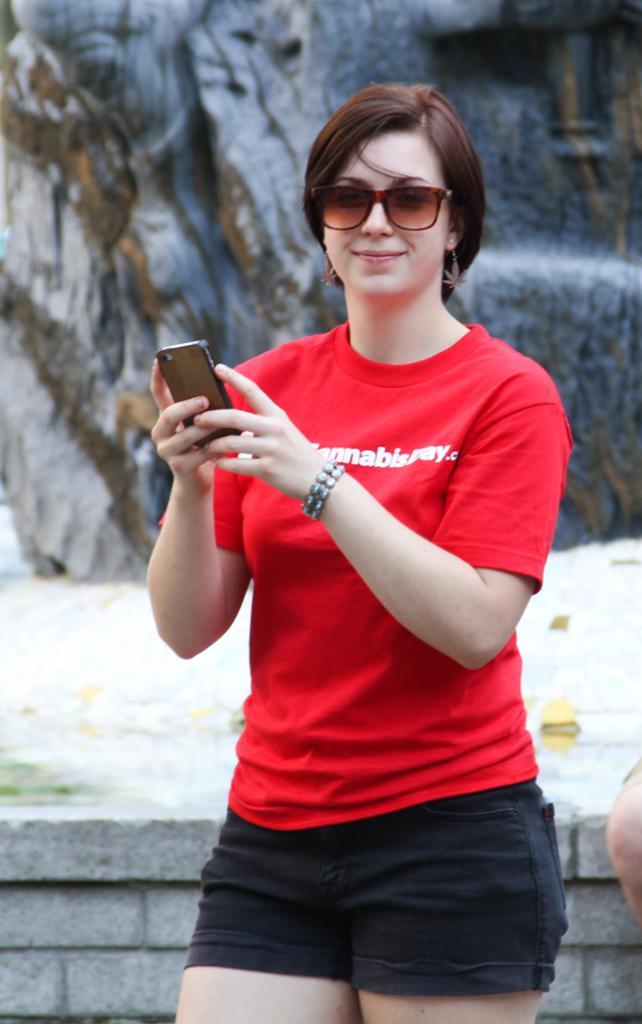Describe this image in one or two sentences. In the middle of the image a woman is standing and holding a mobile phone and smiling. Behind her there is a wall. 